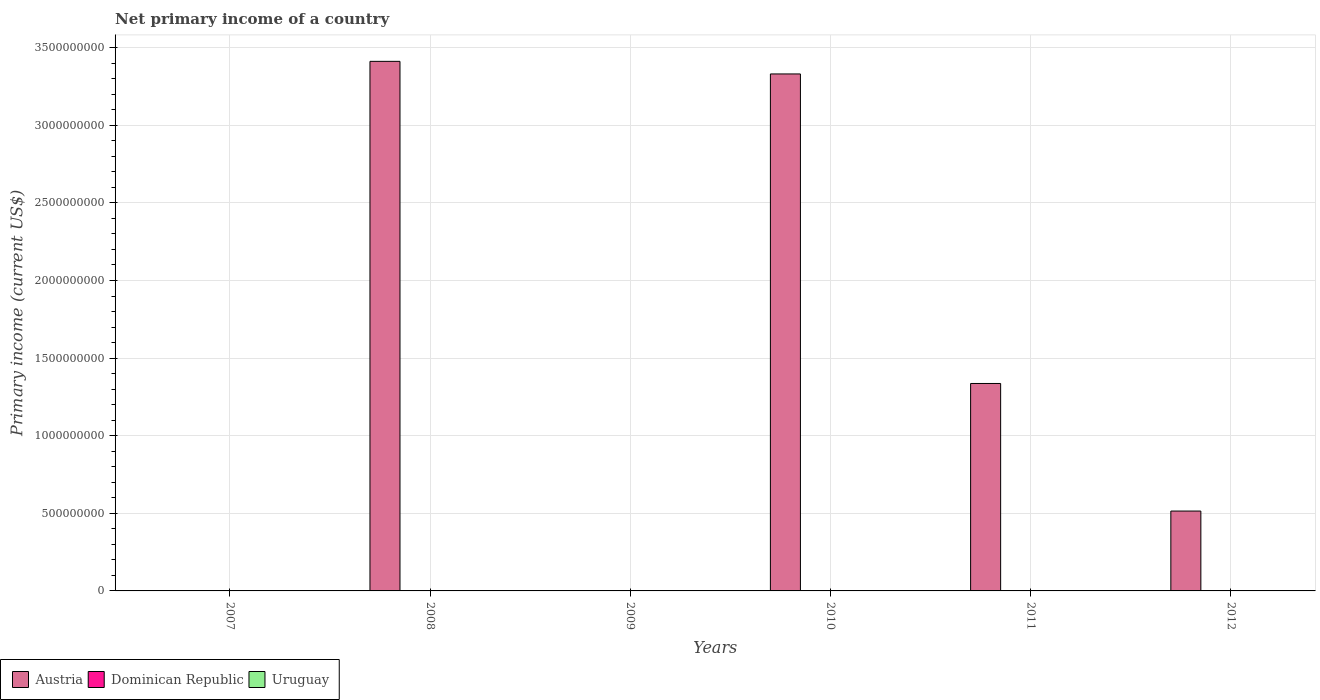What is the label of the 5th group of bars from the left?
Keep it short and to the point. 2011. In how many cases, is the number of bars for a given year not equal to the number of legend labels?
Offer a very short reply. 6. What is the primary income in Austria in 2012?
Make the answer very short. 5.15e+08. Across all years, what is the maximum primary income in Austria?
Your answer should be very brief. 3.41e+09. In which year was the primary income in Austria maximum?
Your answer should be compact. 2008. What is the difference between the primary income in Austria in 2008 and that in 2012?
Ensure brevity in your answer.  2.90e+09. What is the average primary income in Austria per year?
Your answer should be very brief. 1.43e+09. What is the ratio of the primary income in Austria in 2010 to that in 2012?
Give a very brief answer. 6.47. Is the primary income in Austria in 2011 less than that in 2012?
Offer a terse response. No. What is the difference between the highest and the second highest primary income in Austria?
Offer a very short reply. 8.11e+07. What is the difference between the highest and the lowest primary income in Austria?
Keep it short and to the point. 3.41e+09. In how many years, is the primary income in Dominican Republic greater than the average primary income in Dominican Republic taken over all years?
Provide a succinct answer. 0. Are all the bars in the graph horizontal?
Keep it short and to the point. No. Are the values on the major ticks of Y-axis written in scientific E-notation?
Ensure brevity in your answer.  No. Does the graph contain grids?
Provide a short and direct response. Yes. Where does the legend appear in the graph?
Your answer should be very brief. Bottom left. How are the legend labels stacked?
Provide a short and direct response. Horizontal. What is the title of the graph?
Keep it short and to the point. Net primary income of a country. What is the label or title of the X-axis?
Provide a short and direct response. Years. What is the label or title of the Y-axis?
Your response must be concise. Primary income (current US$). What is the Primary income (current US$) in Austria in 2007?
Provide a succinct answer. 0. What is the Primary income (current US$) in Austria in 2008?
Make the answer very short. 3.41e+09. What is the Primary income (current US$) in Austria in 2009?
Make the answer very short. 0. What is the Primary income (current US$) in Austria in 2010?
Your answer should be very brief. 3.33e+09. What is the Primary income (current US$) of Dominican Republic in 2010?
Your response must be concise. 0. What is the Primary income (current US$) in Uruguay in 2010?
Offer a terse response. 0. What is the Primary income (current US$) in Austria in 2011?
Keep it short and to the point. 1.34e+09. What is the Primary income (current US$) in Austria in 2012?
Provide a succinct answer. 5.15e+08. What is the Primary income (current US$) in Uruguay in 2012?
Offer a very short reply. 0. Across all years, what is the maximum Primary income (current US$) of Austria?
Make the answer very short. 3.41e+09. Across all years, what is the minimum Primary income (current US$) in Austria?
Offer a very short reply. 0. What is the total Primary income (current US$) in Austria in the graph?
Give a very brief answer. 8.59e+09. What is the total Primary income (current US$) of Dominican Republic in the graph?
Provide a succinct answer. 0. What is the difference between the Primary income (current US$) in Austria in 2008 and that in 2010?
Offer a terse response. 8.11e+07. What is the difference between the Primary income (current US$) of Austria in 2008 and that in 2011?
Make the answer very short. 2.08e+09. What is the difference between the Primary income (current US$) in Austria in 2008 and that in 2012?
Offer a terse response. 2.90e+09. What is the difference between the Primary income (current US$) of Austria in 2010 and that in 2011?
Offer a terse response. 1.99e+09. What is the difference between the Primary income (current US$) in Austria in 2010 and that in 2012?
Your answer should be very brief. 2.82e+09. What is the difference between the Primary income (current US$) of Austria in 2011 and that in 2012?
Offer a terse response. 8.22e+08. What is the average Primary income (current US$) of Austria per year?
Make the answer very short. 1.43e+09. What is the average Primary income (current US$) in Dominican Republic per year?
Ensure brevity in your answer.  0. What is the ratio of the Primary income (current US$) in Austria in 2008 to that in 2010?
Provide a short and direct response. 1.02. What is the ratio of the Primary income (current US$) in Austria in 2008 to that in 2011?
Give a very brief answer. 2.55. What is the ratio of the Primary income (current US$) of Austria in 2008 to that in 2012?
Offer a terse response. 6.63. What is the ratio of the Primary income (current US$) in Austria in 2010 to that in 2011?
Your answer should be very brief. 2.49. What is the ratio of the Primary income (current US$) of Austria in 2010 to that in 2012?
Ensure brevity in your answer.  6.47. What is the ratio of the Primary income (current US$) in Austria in 2011 to that in 2012?
Your response must be concise. 2.6. What is the difference between the highest and the second highest Primary income (current US$) in Austria?
Your answer should be very brief. 8.11e+07. What is the difference between the highest and the lowest Primary income (current US$) in Austria?
Provide a short and direct response. 3.41e+09. 